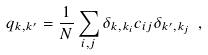Convert formula to latex. <formula><loc_0><loc_0><loc_500><loc_500>q _ { k , k ^ { \prime } } = \frac { 1 } { N } \sum _ { i , j } \delta _ { k , k _ { i } } c _ { i j } \delta _ { k ^ { \prime } , k _ { j } } \ ,</formula> 